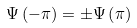Convert formula to latex. <formula><loc_0><loc_0><loc_500><loc_500>\Psi \left ( - \pi \right ) = \pm \Psi \left ( \pi \right )</formula> 